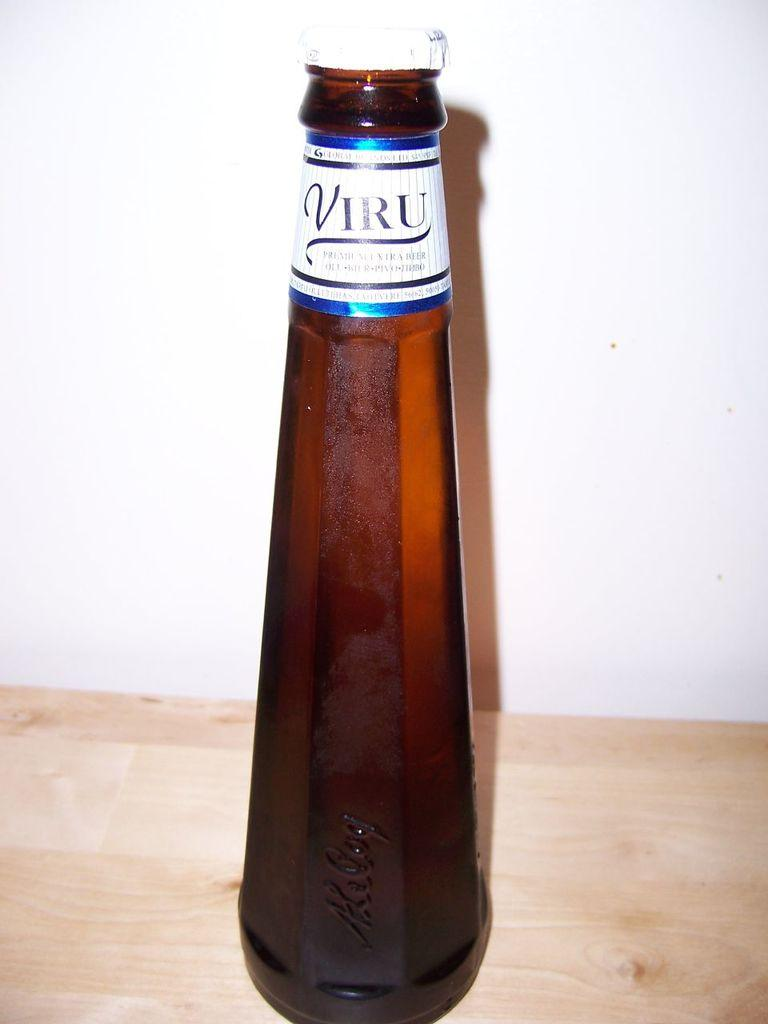<image>
Render a clear and concise summary of the photo. An odd shaped bottle of VIRU beer sits on a wooden counter. 